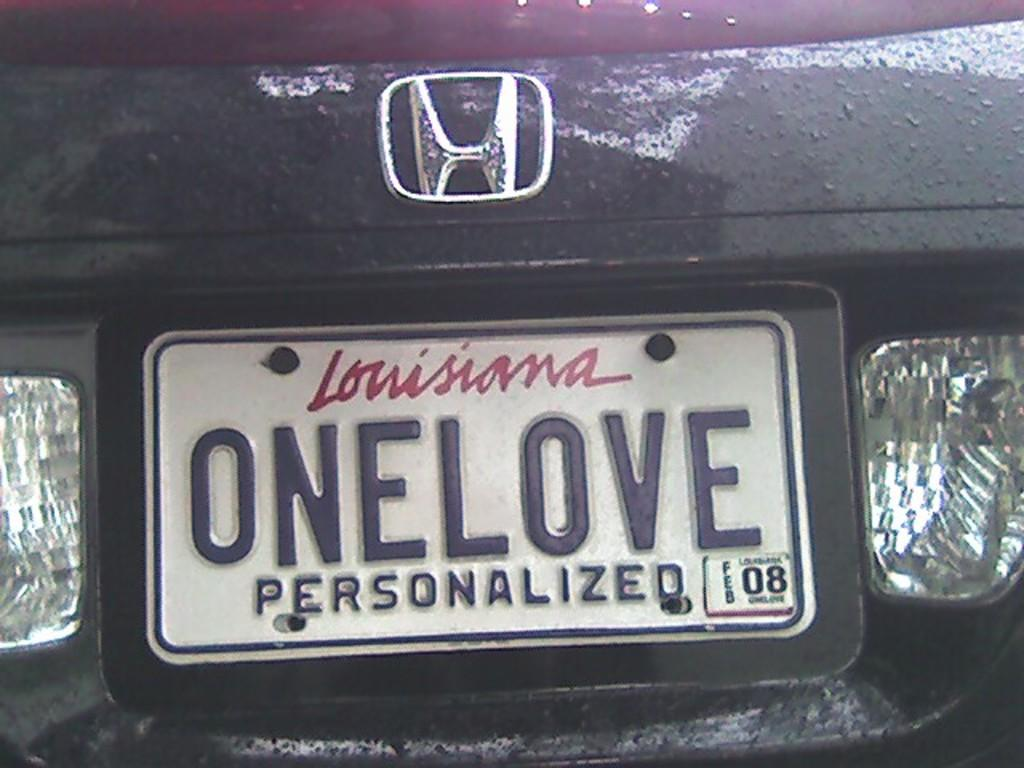<image>
Share a concise interpretation of the image provided. A customized license plate is on a Honda car with the word ONELOVE. 